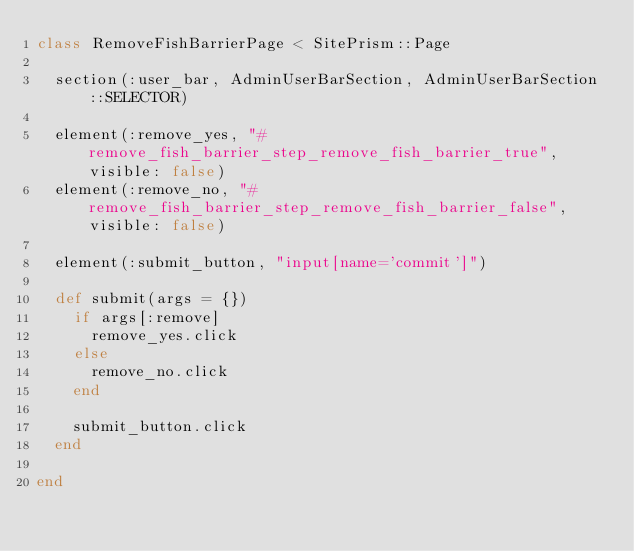<code> <loc_0><loc_0><loc_500><loc_500><_Ruby_>class RemoveFishBarrierPage < SitePrism::Page

  section(:user_bar, AdminUserBarSection, AdminUserBarSection::SELECTOR)

  element(:remove_yes, "#remove_fish_barrier_step_remove_fish_barrier_true", visible: false)
  element(:remove_no, "#remove_fish_barrier_step_remove_fish_barrier_false", visible: false)

  element(:submit_button, "input[name='commit']")

  def submit(args = {})
    if args[:remove]
      remove_yes.click
    else
      remove_no.click
    end

    submit_button.click
  end

end
</code> 